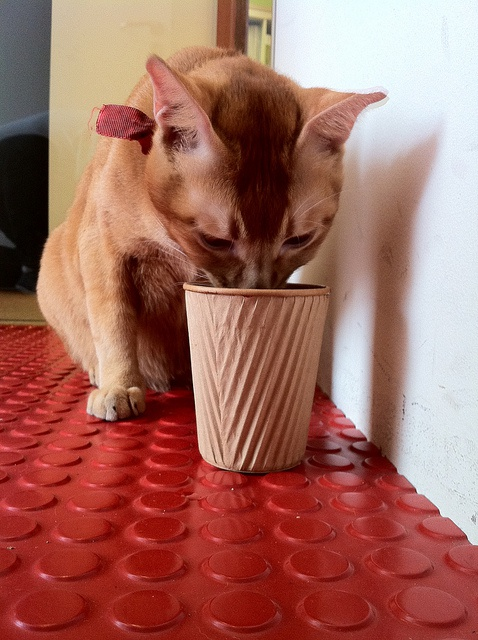Describe the objects in this image and their specific colors. I can see cat in gray, maroon, brown, and tan tones and cup in gray, brown, tan, and maroon tones in this image. 